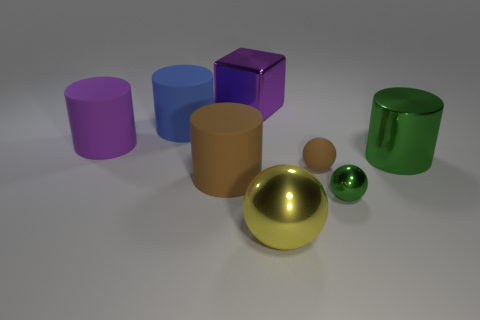There is a small object that is the same color as the large shiny cylinder; what is its shape?
Your answer should be compact. Sphere. How many cylinders are to the left of the large brown object?
Your answer should be very brief. 2. Is there a cyan metallic cylinder that has the same size as the yellow shiny thing?
Your answer should be compact. No. The other shiny thing that is the same shape as the big brown thing is what color?
Make the answer very short. Green. Does the green metallic object that is behind the tiny green object have the same size as the green object that is in front of the green cylinder?
Make the answer very short. No. Are there any other large rubber objects of the same shape as the big yellow thing?
Provide a succinct answer. No. Are there the same number of purple cylinders that are on the right side of the small green sphere and large blue rubber cylinders?
Provide a short and direct response. No. There is a yellow metal thing; is its size the same as the cylinder on the right side of the big yellow metallic ball?
Keep it short and to the point. Yes. How many big purple cylinders have the same material as the tiny green ball?
Provide a short and direct response. 0. Does the purple metal block have the same size as the blue matte object?
Your response must be concise. Yes. 